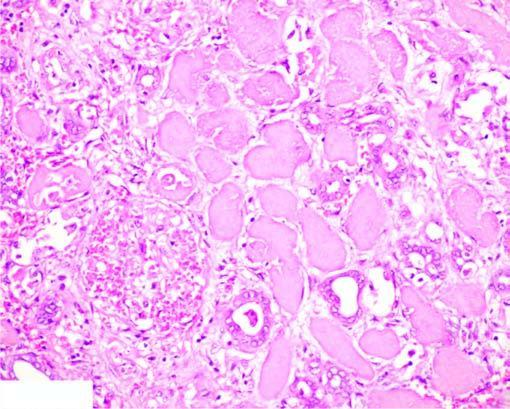what does the affected area on right show?
Answer the question using a single word or phrase. Cells with intensely eosinophilic cytoplasm of tubular cells 